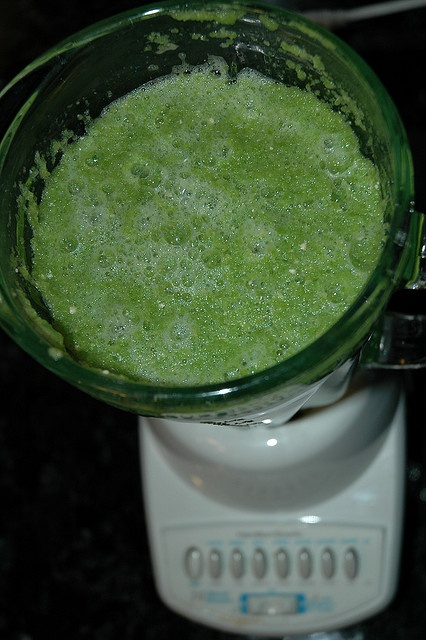Describe the objects in this image and their specific colors. I can see various objects in this image with different colors. 